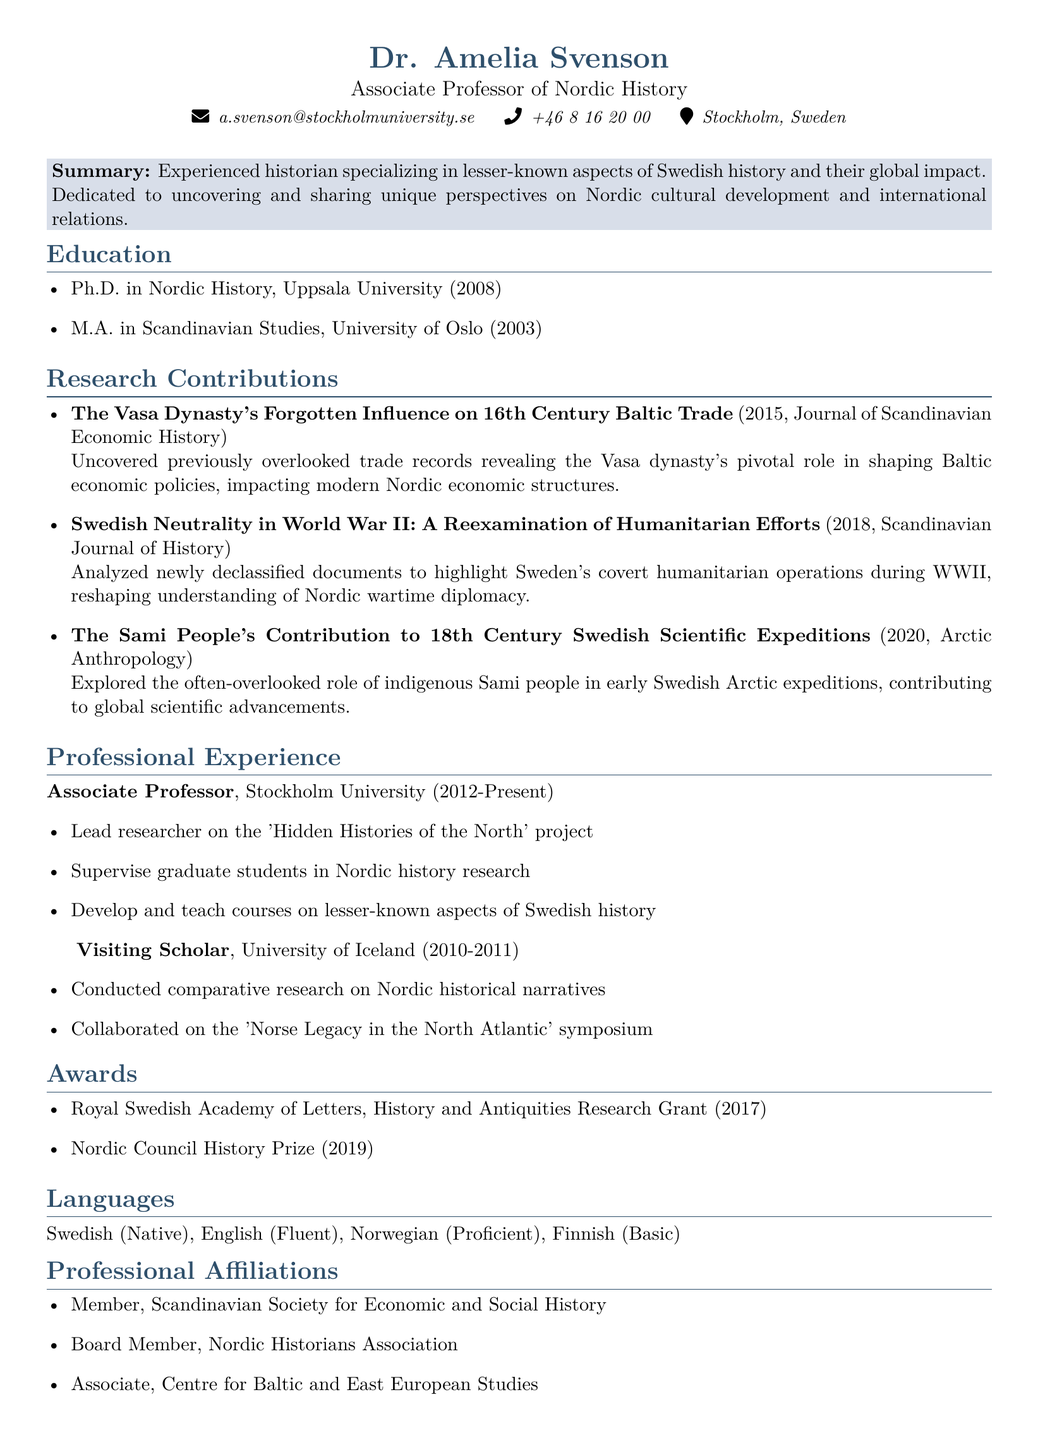what is the name of the associate professor? The document states the name of the associate professor is Dr. Amelia Svenson.
Answer: Dr. Amelia Svenson what is the title of the publication from 2015? The title of the publication from 2015 is "The Vasa Dynasty's Forgotten Influence on 16th Century Baltic Trade".
Answer: The Vasa Dynasty's Forgotten Influence on 16th Century Baltic Trade which institution did Dr. Svenson receive her Ph.D. from? The document indicates that Dr. Svenson received her Ph.D. from Uppsala University.
Answer: Uppsala University how many languages does Dr. Svenson speak? The document lists four languages that Dr. Svenson speaks, indicating her proficiency levels.
Answer: Four which award did Dr. Svenson receive in 2019? According to the document, Dr. Svenson received the Nordic Council History Prize in 2019.
Answer: Nordic Council History Prize what project does Dr. Svenson lead at Stockholm University? The document states that Dr. Svenson is the lead researcher on the 'Hidden Histories of the North' project.
Answer: Hidden Histories of the North who collaborated on the 'Norse Legacy in the North Atlantic' symposium? The document notes that Dr. Svenson was a visiting scholar at the University of Iceland and conducted research there.
Answer: Dr. Svenson what is the focus of Dr. Svenson's research contributions? The summary highlights that Dr. Svenson's research focuses on lesser-known aspects of Swedish history and their global impact.
Answer: Lesser-known aspects of Swedish history and their global impact 